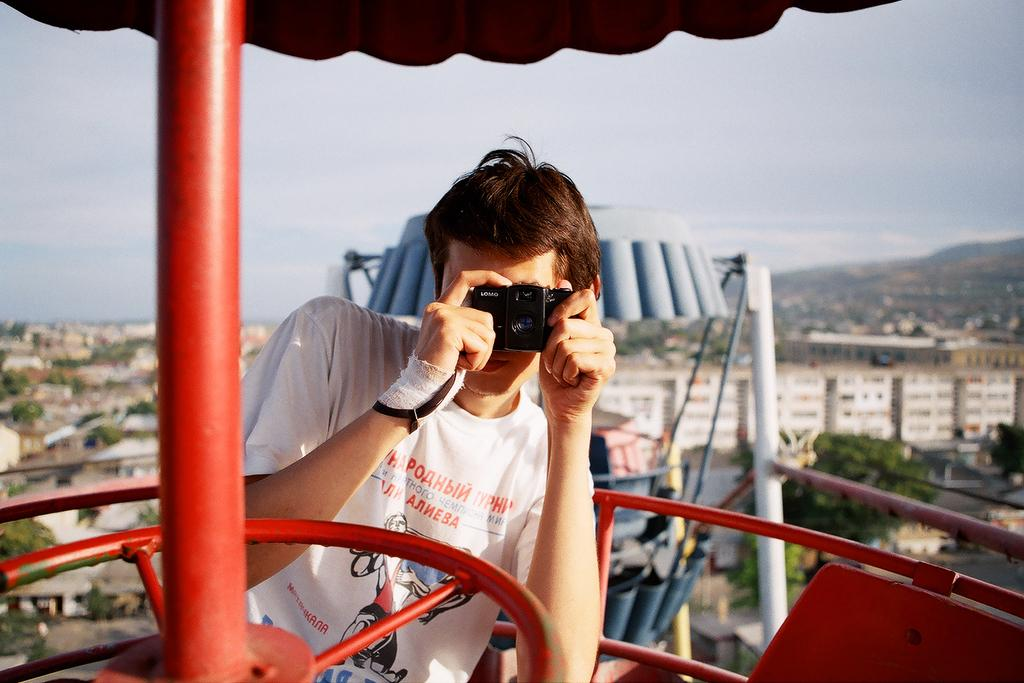What is the man in the image holding? The man is holding a camera in the image. What can be seen in the foreground of the image? There is a red color pole in the foreground of the image. What can be seen in the background of the image? There are buildings and trees in the distance. How many icicles are hanging from the trees in the image? There are no icicles present in the image, as it does not depict a winter scene or any frozen precipitation. 